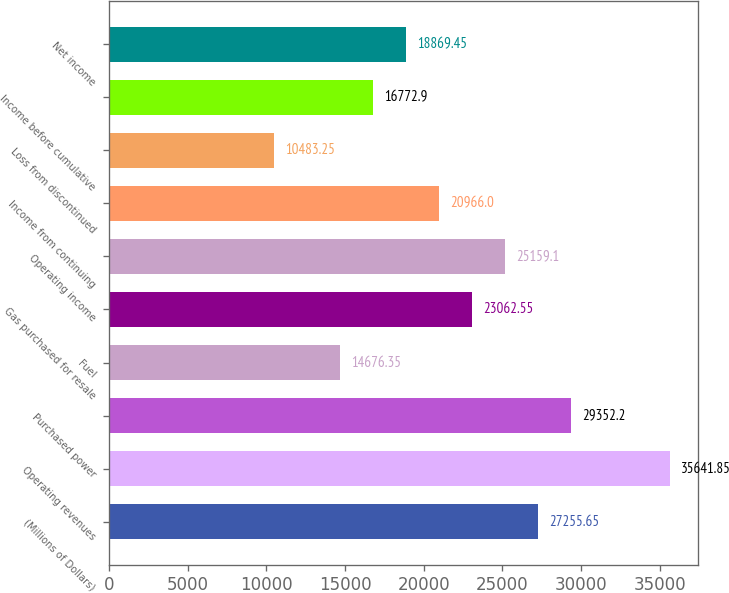Convert chart. <chart><loc_0><loc_0><loc_500><loc_500><bar_chart><fcel>(Millions of Dollars)<fcel>Operating revenues<fcel>Purchased power<fcel>Fuel<fcel>Gas purchased for resale<fcel>Operating income<fcel>Income from continuing<fcel>Loss from discontinued<fcel>Income before cumulative<fcel>Net income<nl><fcel>27255.7<fcel>35641.8<fcel>29352.2<fcel>14676.4<fcel>23062.5<fcel>25159.1<fcel>20966<fcel>10483.2<fcel>16772.9<fcel>18869.5<nl></chart> 